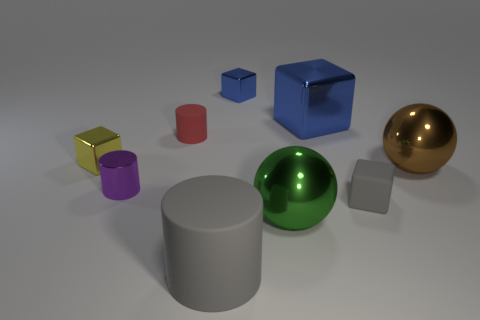Subtract all yellow blocks. How many blocks are left? 3 Subtract all small gray rubber cubes. How many cubes are left? 3 Subtract all cyan blocks. Subtract all cyan cylinders. How many blocks are left? 4 Add 1 small matte cylinders. How many objects exist? 10 Subtract all spheres. How many objects are left? 7 Add 9 big yellow matte spheres. How many big yellow matte spheres exist? 9 Subtract 1 gray cubes. How many objects are left? 8 Subtract all tiny blue cylinders. Subtract all large matte cylinders. How many objects are left? 8 Add 5 green metallic spheres. How many green metallic spheres are left? 6 